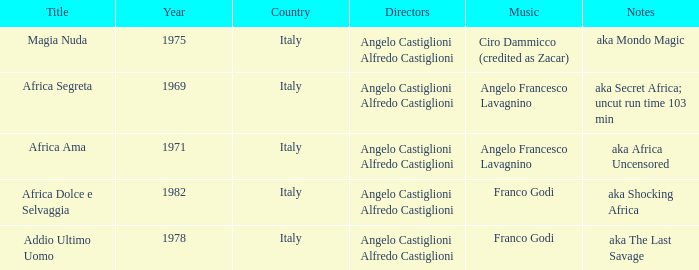How many years have a Title of Magia Nuda? 1.0. 